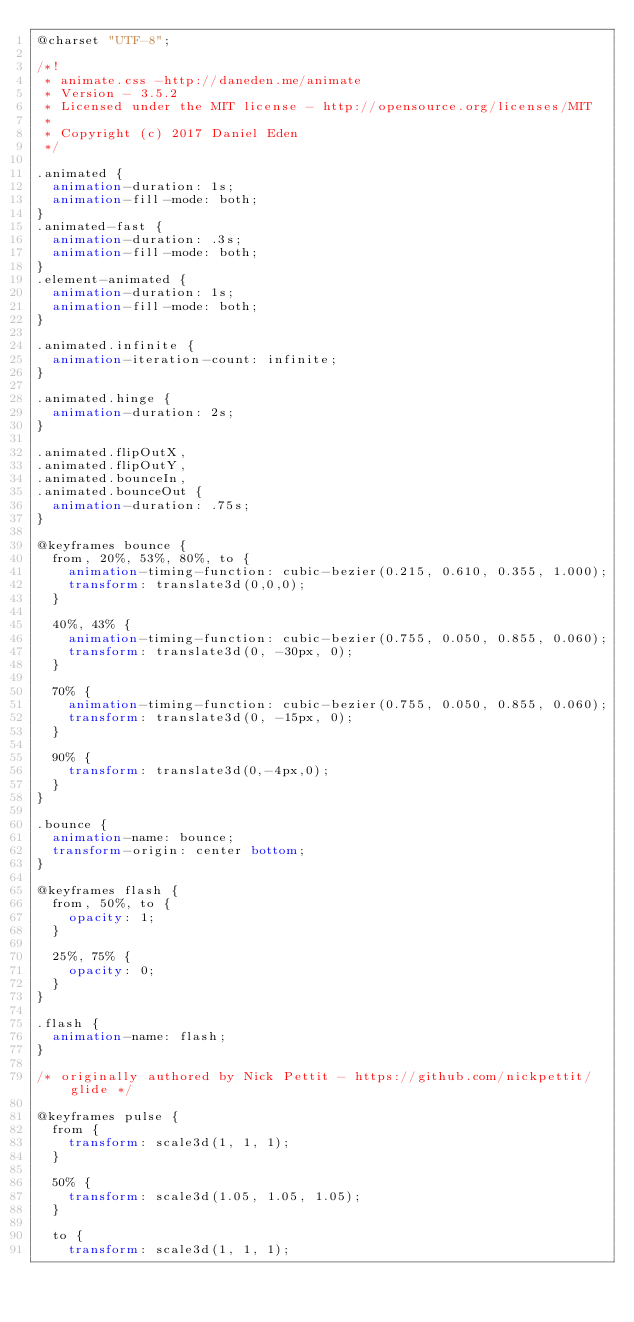Convert code to text. <code><loc_0><loc_0><loc_500><loc_500><_CSS_>@charset "UTF-8";

/*!
 * animate.css -http://daneden.me/animate
 * Version - 3.5.2
 * Licensed under the MIT license - http://opensource.org/licenses/MIT
 *
 * Copyright (c) 2017 Daniel Eden
 */

.animated {
  animation-duration: 1s;
  animation-fill-mode: both;
}
.animated-fast {
  animation-duration: .3s;
  animation-fill-mode: both;
}
.element-animated {
  animation-duration: 1s;
  animation-fill-mode: both;
}

.animated.infinite {
  animation-iteration-count: infinite;
}

.animated.hinge {
  animation-duration: 2s;
}

.animated.flipOutX,
.animated.flipOutY,
.animated.bounceIn,
.animated.bounceOut {
  animation-duration: .75s;
}

@keyframes bounce {
  from, 20%, 53%, 80%, to {
    animation-timing-function: cubic-bezier(0.215, 0.610, 0.355, 1.000);
    transform: translate3d(0,0,0);
  }

  40%, 43% {
    animation-timing-function: cubic-bezier(0.755, 0.050, 0.855, 0.060);
    transform: translate3d(0, -30px, 0);
  }

  70% {
    animation-timing-function: cubic-bezier(0.755, 0.050, 0.855, 0.060);
    transform: translate3d(0, -15px, 0);
  }

  90% {
    transform: translate3d(0,-4px,0);
  }
}

.bounce {
  animation-name: bounce;
  transform-origin: center bottom;
}

@keyframes flash {
  from, 50%, to {
    opacity: 1;
  }

  25%, 75% {
    opacity: 0;
  }
}

.flash {
  animation-name: flash;
}

/* originally authored by Nick Pettit - https://github.com/nickpettit/glide */

@keyframes pulse {
  from {
    transform: scale3d(1, 1, 1);
  }

  50% {
    transform: scale3d(1.05, 1.05, 1.05);
  }

  to {
    transform: scale3d(1, 1, 1);</code> 